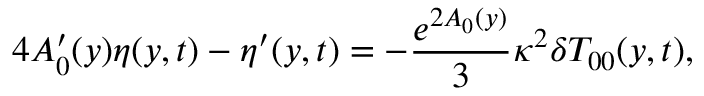<formula> <loc_0><loc_0><loc_500><loc_500>4 A _ { 0 } ^ { \prime } ( y ) \eta ( y , t ) - \eta ^ { \prime } ( y , t ) = - \frac { e ^ { 2 A _ { 0 } ( y ) } } { 3 } \kappa ^ { 2 } \delta T _ { 0 0 } ( y , t ) ,</formula> 